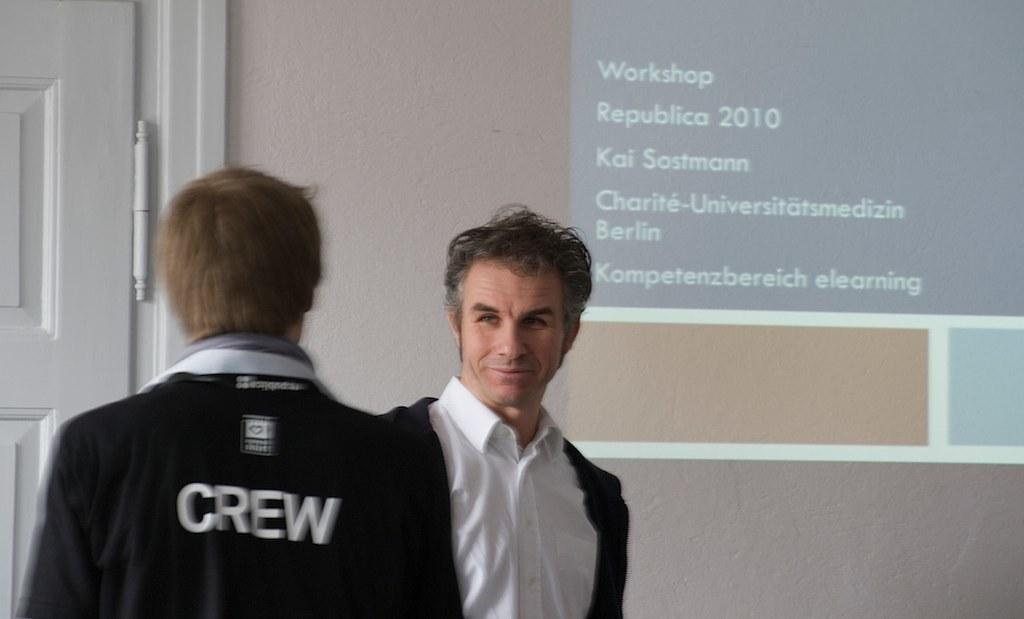How many people are in the image? There are two persons in the image. What are the persons wearing? Both persons are wearing white shirts and black jackets. Where are the persons standing? The persons are standing in front of a wall. What is on the wall? There is a projector screen on the wall. What architectural feature can be seen on the left side of the image? There is a door on the left side of the image. What type of iron is hanging from the ceiling in the image? There is no iron hanging from the ceiling in the image. How many icicles can be seen on the projector screen? There are no icicles present in the image; it features a projector screen on a wall. What time does the watch on the wall show in the image? There is no watch present in the image. 